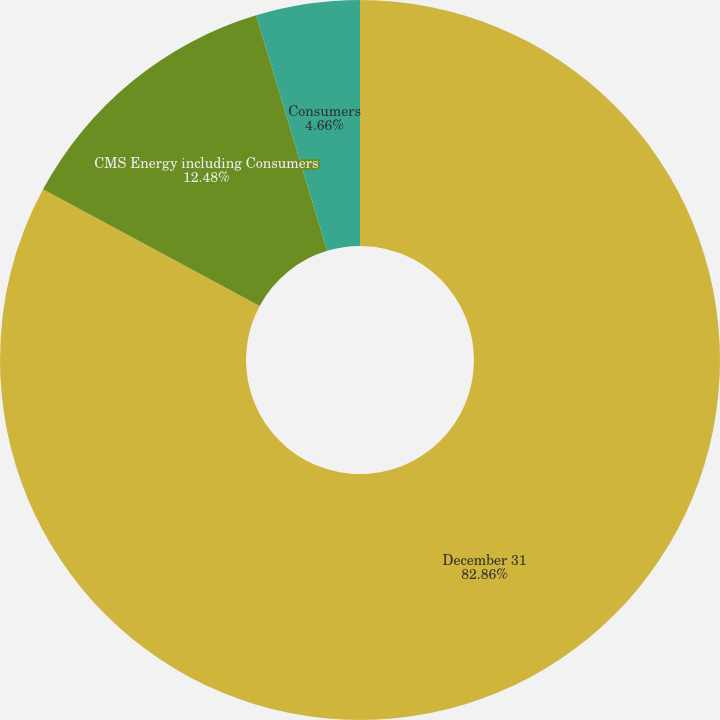Convert chart. <chart><loc_0><loc_0><loc_500><loc_500><pie_chart><fcel>December 31<fcel>CMS Energy including Consumers<fcel>Consumers<nl><fcel>82.86%<fcel>12.48%<fcel>4.66%<nl></chart> 